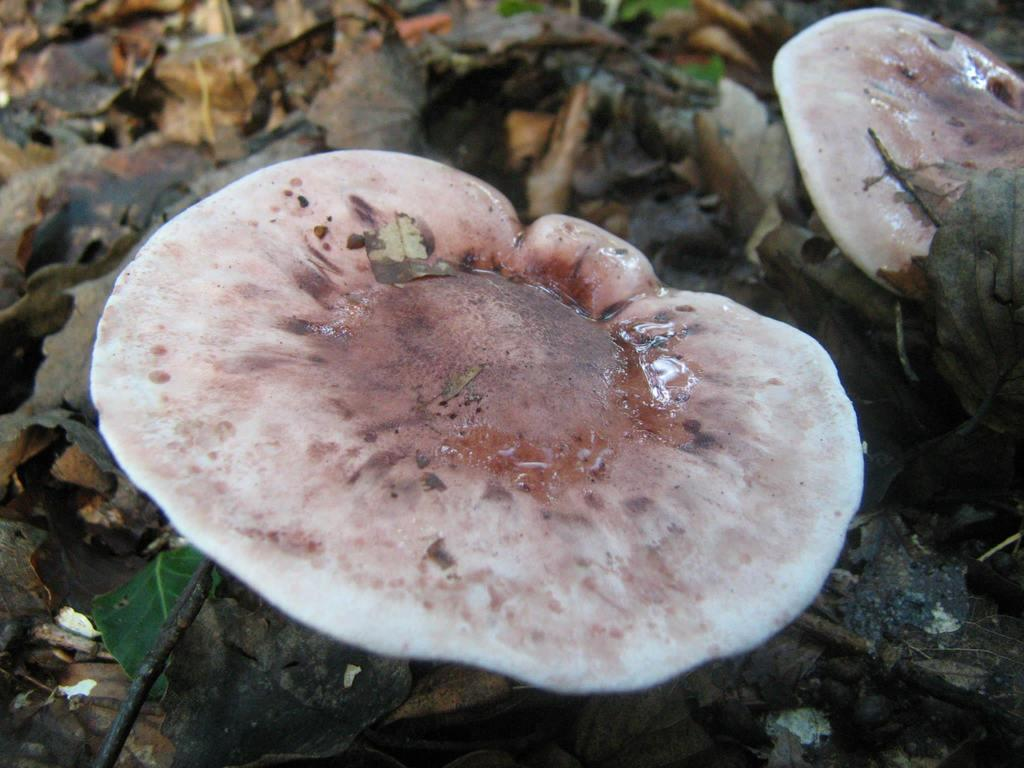What is the main subject of the image? The main subject of the image is a mushroom. Can you describe the image details be observed closely? Yes, the image is a zoomed-in picture of the mushroom. What can be seen in the background of the image? Dry leaves are present in the background of the image. Who is the creator of the mushroom in the image? The image is a photograph, and mushrooms are naturally occurring organisms, so there is no specific creator for the mushroom in the image. 